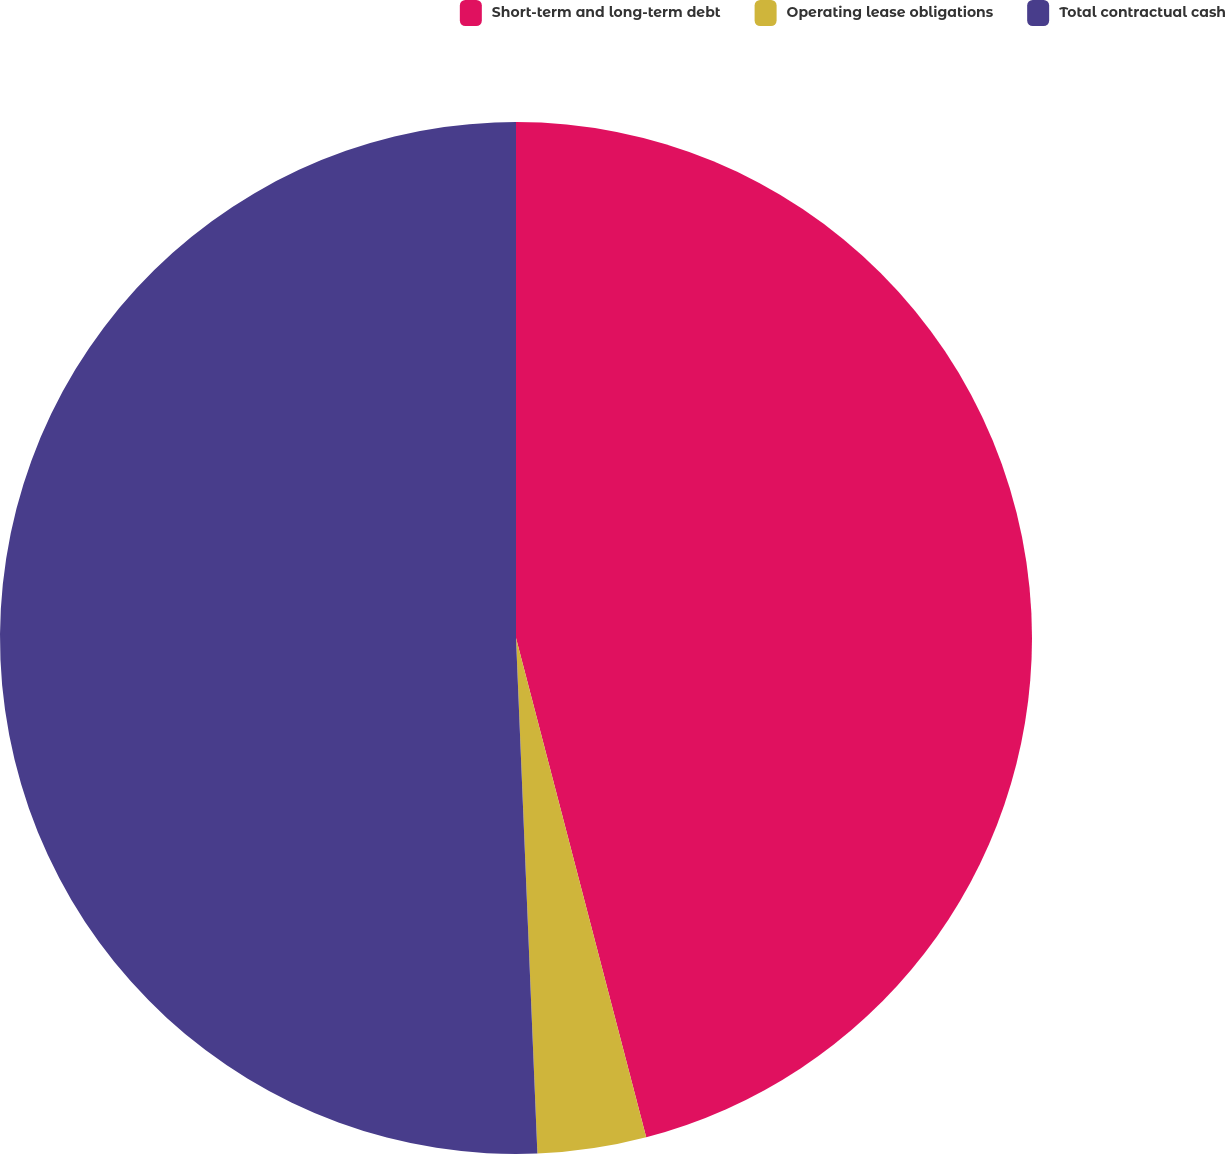Convert chart to OTSL. <chart><loc_0><loc_0><loc_500><loc_500><pie_chart><fcel>Short-term and long-term debt<fcel>Operating lease obligations<fcel>Total contractual cash<nl><fcel>45.94%<fcel>3.4%<fcel>50.66%<nl></chart> 